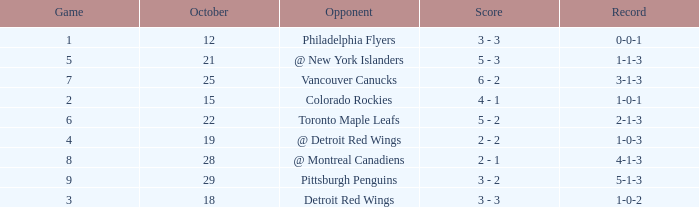Name the most october for game less than 1 None. 